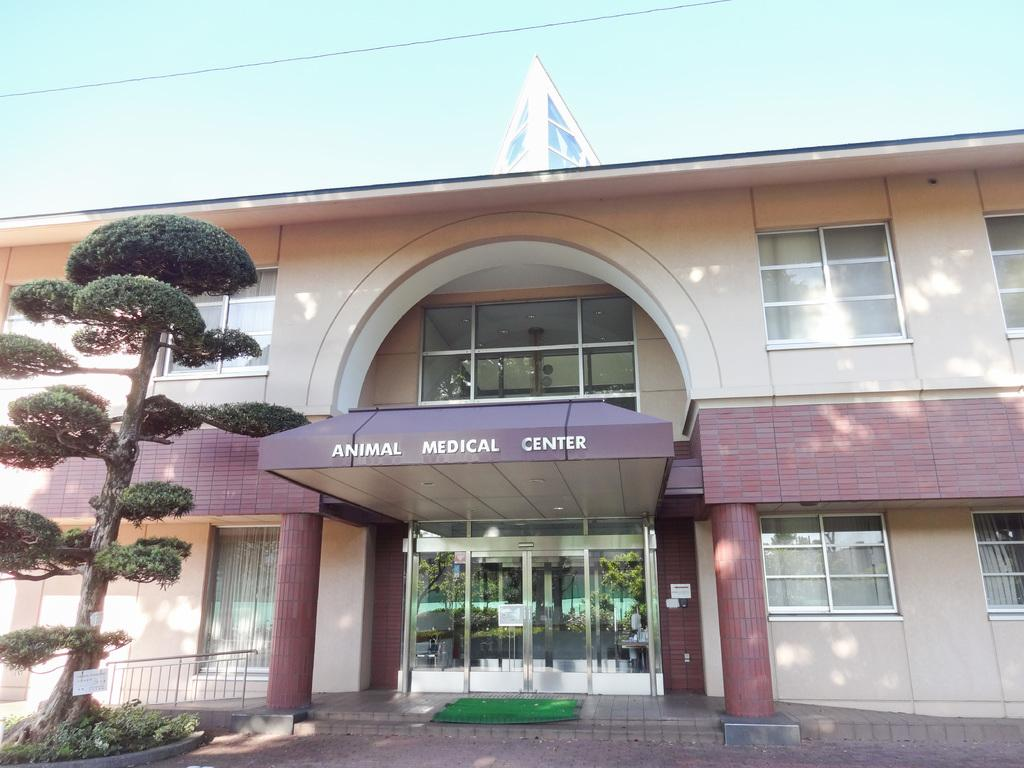What type of structure is in the image? There is a building in the image. What is written on the building? The name "Animal Medical Center" is written on the building. What is located to the left of the building? There is a tree to the left of the building. What can be seen in the background of the image? The sky is visible in the background of the image, and it is blue. How many lights can be seen in the mouth of the building in the image? There are no lights or mouths present in the image, as it features a building with the name "Animal Medical Center" and a tree to the left. 